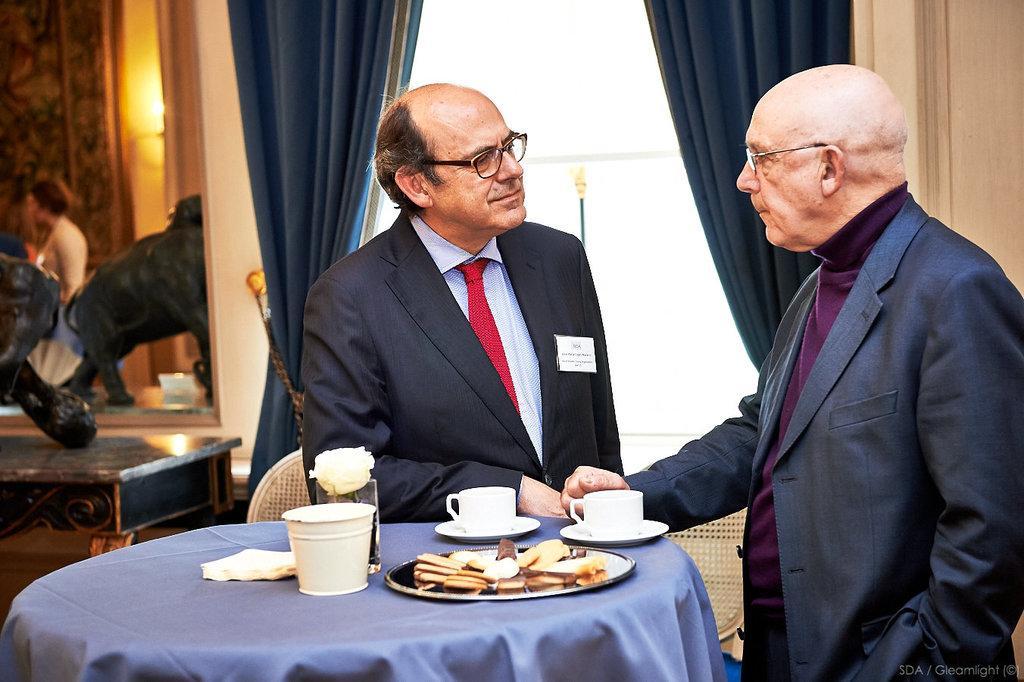Please provide a concise description of this image. In the image we can see there are men who are standing and they are shaking their hands and on table there are cups soccer and in plate there are biscuits. 